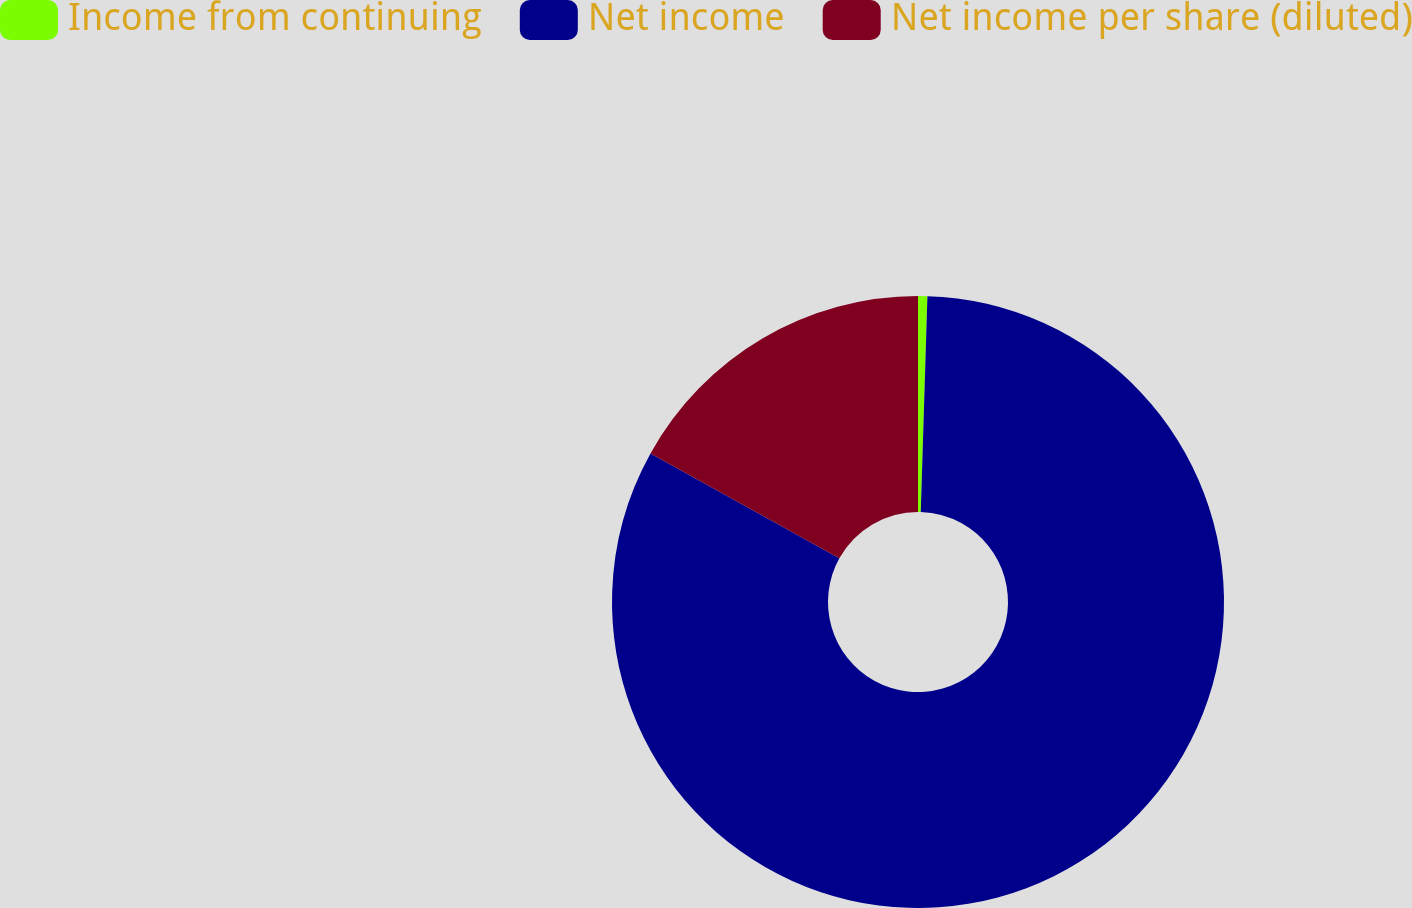<chart> <loc_0><loc_0><loc_500><loc_500><pie_chart><fcel>Income from continuing<fcel>Net income<fcel>Net income per share (diluted)<nl><fcel>0.49%<fcel>82.58%<fcel>16.93%<nl></chart> 